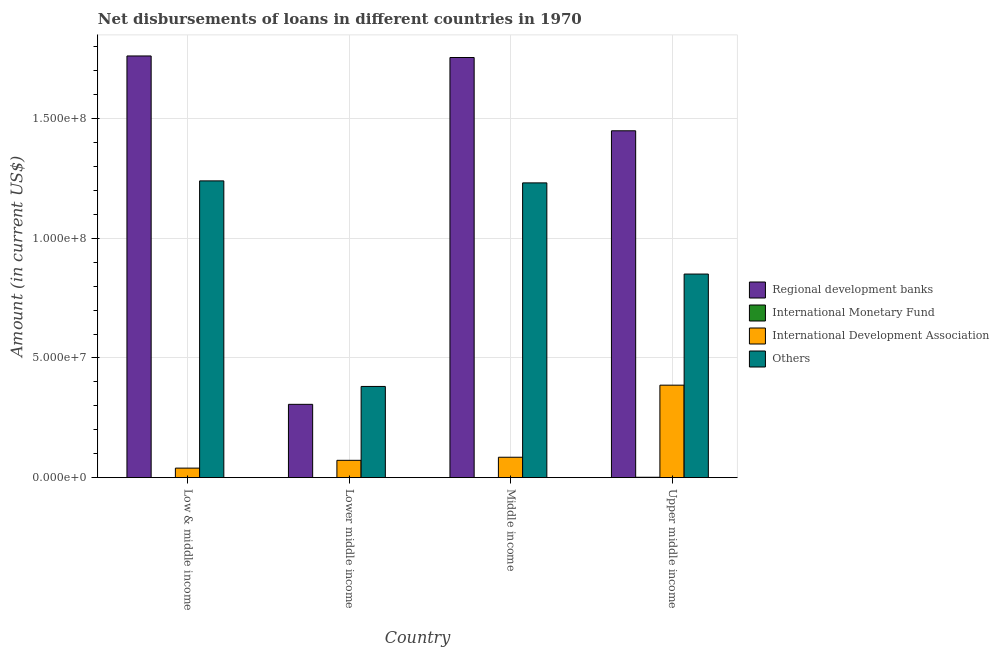How many different coloured bars are there?
Keep it short and to the point. 4. How many groups of bars are there?
Make the answer very short. 4. Are the number of bars per tick equal to the number of legend labels?
Your answer should be very brief. No. How many bars are there on the 3rd tick from the right?
Make the answer very short. 3. What is the label of the 3rd group of bars from the left?
Offer a terse response. Middle income. In how many cases, is the number of bars for a given country not equal to the number of legend labels?
Your response must be concise. 3. What is the amount of loan disimbursed by other organisations in Lower middle income?
Provide a succinct answer. 3.81e+07. Across all countries, what is the maximum amount of loan disimbursed by international development association?
Provide a short and direct response. 3.86e+07. Across all countries, what is the minimum amount of loan disimbursed by regional development banks?
Offer a very short reply. 3.06e+07. In which country was the amount of loan disimbursed by international monetary fund maximum?
Give a very brief answer. Upper middle income. What is the total amount of loan disimbursed by regional development banks in the graph?
Offer a very short reply. 5.27e+08. What is the difference between the amount of loan disimbursed by regional development banks in Lower middle income and that in Upper middle income?
Your response must be concise. -1.14e+08. What is the difference between the amount of loan disimbursed by regional development banks in Lower middle income and the amount of loan disimbursed by international monetary fund in Middle income?
Make the answer very short. 3.06e+07. What is the average amount of loan disimbursed by international development association per country?
Your answer should be very brief. 1.46e+07. What is the difference between the amount of loan disimbursed by international development association and amount of loan disimbursed by other organisations in Middle income?
Keep it short and to the point. -1.15e+08. What is the ratio of the amount of loan disimbursed by other organisations in Lower middle income to that in Middle income?
Make the answer very short. 0.31. What is the difference between the highest and the second highest amount of loan disimbursed by other organisations?
Your answer should be very brief. 8.35e+05. What is the difference between the highest and the lowest amount of loan disimbursed by other organisations?
Provide a short and direct response. 8.59e+07. Is the sum of the amount of loan disimbursed by international development association in Low & middle income and Lower middle income greater than the maximum amount of loan disimbursed by regional development banks across all countries?
Your answer should be compact. No. Is it the case that in every country, the sum of the amount of loan disimbursed by regional development banks and amount of loan disimbursed by international monetary fund is greater than the amount of loan disimbursed by international development association?
Offer a terse response. Yes. How many bars are there?
Ensure brevity in your answer.  13. How many countries are there in the graph?
Provide a short and direct response. 4. Are the values on the major ticks of Y-axis written in scientific E-notation?
Make the answer very short. Yes. Does the graph contain any zero values?
Offer a very short reply. Yes. Does the graph contain grids?
Make the answer very short. Yes. Where does the legend appear in the graph?
Make the answer very short. Center right. What is the title of the graph?
Give a very brief answer. Net disbursements of loans in different countries in 1970. What is the label or title of the X-axis?
Give a very brief answer. Country. What is the label or title of the Y-axis?
Offer a terse response. Amount (in current US$). What is the Amount (in current US$) in Regional development banks in Low & middle income?
Make the answer very short. 1.76e+08. What is the Amount (in current US$) in International Monetary Fund in Low & middle income?
Provide a short and direct response. 0. What is the Amount (in current US$) of International Development Association in Low & middle income?
Keep it short and to the point. 3.98e+06. What is the Amount (in current US$) of Others in Low & middle income?
Provide a short and direct response. 1.24e+08. What is the Amount (in current US$) in Regional development banks in Lower middle income?
Keep it short and to the point. 3.06e+07. What is the Amount (in current US$) in International Monetary Fund in Lower middle income?
Your answer should be very brief. 0. What is the Amount (in current US$) of International Development Association in Lower middle income?
Provide a succinct answer. 7.23e+06. What is the Amount (in current US$) in Others in Lower middle income?
Keep it short and to the point. 3.81e+07. What is the Amount (in current US$) in Regional development banks in Middle income?
Your answer should be compact. 1.76e+08. What is the Amount (in current US$) of International Monetary Fund in Middle income?
Your answer should be very brief. 0. What is the Amount (in current US$) of International Development Association in Middle income?
Offer a very short reply. 8.52e+06. What is the Amount (in current US$) of Others in Middle income?
Your response must be concise. 1.23e+08. What is the Amount (in current US$) of Regional development banks in Upper middle income?
Your answer should be very brief. 1.45e+08. What is the Amount (in current US$) of International Monetary Fund in Upper middle income?
Your response must be concise. 1.50e+05. What is the Amount (in current US$) in International Development Association in Upper middle income?
Keep it short and to the point. 3.86e+07. What is the Amount (in current US$) in Others in Upper middle income?
Your answer should be very brief. 8.51e+07. Across all countries, what is the maximum Amount (in current US$) of Regional development banks?
Provide a short and direct response. 1.76e+08. Across all countries, what is the maximum Amount (in current US$) of International Monetary Fund?
Offer a very short reply. 1.50e+05. Across all countries, what is the maximum Amount (in current US$) of International Development Association?
Provide a short and direct response. 3.86e+07. Across all countries, what is the maximum Amount (in current US$) in Others?
Your answer should be very brief. 1.24e+08. Across all countries, what is the minimum Amount (in current US$) in Regional development banks?
Provide a short and direct response. 3.06e+07. Across all countries, what is the minimum Amount (in current US$) in International Development Association?
Provide a short and direct response. 3.98e+06. Across all countries, what is the minimum Amount (in current US$) in Others?
Provide a short and direct response. 3.81e+07. What is the total Amount (in current US$) in Regional development banks in the graph?
Your response must be concise. 5.27e+08. What is the total Amount (in current US$) of International Monetary Fund in the graph?
Give a very brief answer. 1.50e+05. What is the total Amount (in current US$) in International Development Association in the graph?
Your answer should be compact. 5.84e+07. What is the total Amount (in current US$) in Others in the graph?
Make the answer very short. 3.70e+08. What is the difference between the Amount (in current US$) of Regional development banks in Low & middle income and that in Lower middle income?
Provide a short and direct response. 1.46e+08. What is the difference between the Amount (in current US$) in International Development Association in Low & middle income and that in Lower middle income?
Keep it short and to the point. -3.26e+06. What is the difference between the Amount (in current US$) in Others in Low & middle income and that in Lower middle income?
Ensure brevity in your answer.  8.59e+07. What is the difference between the Amount (in current US$) of Regional development banks in Low & middle income and that in Middle income?
Provide a short and direct response. 6.47e+05. What is the difference between the Amount (in current US$) of International Development Association in Low & middle income and that in Middle income?
Make the answer very short. -4.54e+06. What is the difference between the Amount (in current US$) of Others in Low & middle income and that in Middle income?
Offer a very short reply. 8.35e+05. What is the difference between the Amount (in current US$) of Regional development banks in Low & middle income and that in Upper middle income?
Make the answer very short. 3.13e+07. What is the difference between the Amount (in current US$) of International Development Association in Low & middle income and that in Upper middle income?
Your answer should be compact. -3.47e+07. What is the difference between the Amount (in current US$) of Others in Low & middle income and that in Upper middle income?
Your answer should be compact. 3.89e+07. What is the difference between the Amount (in current US$) of Regional development banks in Lower middle income and that in Middle income?
Make the answer very short. -1.45e+08. What is the difference between the Amount (in current US$) in International Development Association in Lower middle income and that in Middle income?
Your answer should be compact. -1.28e+06. What is the difference between the Amount (in current US$) of Others in Lower middle income and that in Middle income?
Your answer should be very brief. -8.51e+07. What is the difference between the Amount (in current US$) of Regional development banks in Lower middle income and that in Upper middle income?
Your answer should be very brief. -1.14e+08. What is the difference between the Amount (in current US$) of International Development Association in Lower middle income and that in Upper middle income?
Ensure brevity in your answer.  -3.14e+07. What is the difference between the Amount (in current US$) of Others in Lower middle income and that in Upper middle income?
Your response must be concise. -4.70e+07. What is the difference between the Amount (in current US$) in Regional development banks in Middle income and that in Upper middle income?
Offer a terse response. 3.06e+07. What is the difference between the Amount (in current US$) of International Development Association in Middle income and that in Upper middle income?
Your response must be concise. -3.01e+07. What is the difference between the Amount (in current US$) of Others in Middle income and that in Upper middle income?
Your answer should be very brief. 3.81e+07. What is the difference between the Amount (in current US$) of Regional development banks in Low & middle income and the Amount (in current US$) of International Development Association in Lower middle income?
Your response must be concise. 1.69e+08. What is the difference between the Amount (in current US$) in Regional development banks in Low & middle income and the Amount (in current US$) in Others in Lower middle income?
Offer a very short reply. 1.38e+08. What is the difference between the Amount (in current US$) of International Development Association in Low & middle income and the Amount (in current US$) of Others in Lower middle income?
Make the answer very short. -3.41e+07. What is the difference between the Amount (in current US$) of Regional development banks in Low & middle income and the Amount (in current US$) of International Development Association in Middle income?
Give a very brief answer. 1.68e+08. What is the difference between the Amount (in current US$) in Regional development banks in Low & middle income and the Amount (in current US$) in Others in Middle income?
Ensure brevity in your answer.  5.30e+07. What is the difference between the Amount (in current US$) in International Development Association in Low & middle income and the Amount (in current US$) in Others in Middle income?
Provide a succinct answer. -1.19e+08. What is the difference between the Amount (in current US$) in Regional development banks in Low & middle income and the Amount (in current US$) in International Monetary Fund in Upper middle income?
Your answer should be compact. 1.76e+08. What is the difference between the Amount (in current US$) in Regional development banks in Low & middle income and the Amount (in current US$) in International Development Association in Upper middle income?
Keep it short and to the point. 1.38e+08. What is the difference between the Amount (in current US$) of Regional development banks in Low & middle income and the Amount (in current US$) of Others in Upper middle income?
Your answer should be compact. 9.11e+07. What is the difference between the Amount (in current US$) of International Development Association in Low & middle income and the Amount (in current US$) of Others in Upper middle income?
Give a very brief answer. -8.11e+07. What is the difference between the Amount (in current US$) in Regional development banks in Lower middle income and the Amount (in current US$) in International Development Association in Middle income?
Provide a succinct answer. 2.21e+07. What is the difference between the Amount (in current US$) in Regional development banks in Lower middle income and the Amount (in current US$) in Others in Middle income?
Offer a very short reply. -9.25e+07. What is the difference between the Amount (in current US$) of International Development Association in Lower middle income and the Amount (in current US$) of Others in Middle income?
Your answer should be compact. -1.16e+08. What is the difference between the Amount (in current US$) of Regional development banks in Lower middle income and the Amount (in current US$) of International Monetary Fund in Upper middle income?
Your response must be concise. 3.05e+07. What is the difference between the Amount (in current US$) in Regional development banks in Lower middle income and the Amount (in current US$) in International Development Association in Upper middle income?
Ensure brevity in your answer.  -8.01e+06. What is the difference between the Amount (in current US$) of Regional development banks in Lower middle income and the Amount (in current US$) of Others in Upper middle income?
Your answer should be compact. -5.44e+07. What is the difference between the Amount (in current US$) in International Development Association in Lower middle income and the Amount (in current US$) in Others in Upper middle income?
Offer a very short reply. -7.78e+07. What is the difference between the Amount (in current US$) in Regional development banks in Middle income and the Amount (in current US$) in International Monetary Fund in Upper middle income?
Give a very brief answer. 1.75e+08. What is the difference between the Amount (in current US$) of Regional development banks in Middle income and the Amount (in current US$) of International Development Association in Upper middle income?
Your answer should be compact. 1.37e+08. What is the difference between the Amount (in current US$) in Regional development banks in Middle income and the Amount (in current US$) in Others in Upper middle income?
Ensure brevity in your answer.  9.05e+07. What is the difference between the Amount (in current US$) of International Development Association in Middle income and the Amount (in current US$) of Others in Upper middle income?
Your answer should be compact. -7.65e+07. What is the average Amount (in current US$) in Regional development banks per country?
Make the answer very short. 1.32e+08. What is the average Amount (in current US$) in International Monetary Fund per country?
Offer a very short reply. 3.75e+04. What is the average Amount (in current US$) in International Development Association per country?
Keep it short and to the point. 1.46e+07. What is the average Amount (in current US$) of Others per country?
Your answer should be very brief. 9.26e+07. What is the difference between the Amount (in current US$) in Regional development banks and Amount (in current US$) in International Development Association in Low & middle income?
Your answer should be very brief. 1.72e+08. What is the difference between the Amount (in current US$) of Regional development banks and Amount (in current US$) of Others in Low & middle income?
Your answer should be compact. 5.22e+07. What is the difference between the Amount (in current US$) in International Development Association and Amount (in current US$) in Others in Low & middle income?
Your answer should be very brief. -1.20e+08. What is the difference between the Amount (in current US$) of Regional development banks and Amount (in current US$) of International Development Association in Lower middle income?
Your answer should be compact. 2.34e+07. What is the difference between the Amount (in current US$) of Regional development banks and Amount (in current US$) of Others in Lower middle income?
Keep it short and to the point. -7.48e+06. What is the difference between the Amount (in current US$) in International Development Association and Amount (in current US$) in Others in Lower middle income?
Keep it short and to the point. -3.09e+07. What is the difference between the Amount (in current US$) of Regional development banks and Amount (in current US$) of International Development Association in Middle income?
Make the answer very short. 1.67e+08. What is the difference between the Amount (in current US$) of Regional development banks and Amount (in current US$) of Others in Middle income?
Make the answer very short. 5.24e+07. What is the difference between the Amount (in current US$) of International Development Association and Amount (in current US$) of Others in Middle income?
Your response must be concise. -1.15e+08. What is the difference between the Amount (in current US$) of Regional development banks and Amount (in current US$) of International Monetary Fund in Upper middle income?
Your answer should be very brief. 1.45e+08. What is the difference between the Amount (in current US$) in Regional development banks and Amount (in current US$) in International Development Association in Upper middle income?
Keep it short and to the point. 1.06e+08. What is the difference between the Amount (in current US$) of Regional development banks and Amount (in current US$) of Others in Upper middle income?
Give a very brief answer. 5.99e+07. What is the difference between the Amount (in current US$) in International Monetary Fund and Amount (in current US$) in International Development Association in Upper middle income?
Provide a succinct answer. -3.85e+07. What is the difference between the Amount (in current US$) in International Monetary Fund and Amount (in current US$) in Others in Upper middle income?
Provide a short and direct response. -8.49e+07. What is the difference between the Amount (in current US$) in International Development Association and Amount (in current US$) in Others in Upper middle income?
Offer a terse response. -4.64e+07. What is the ratio of the Amount (in current US$) of Regional development banks in Low & middle income to that in Lower middle income?
Give a very brief answer. 5.75. What is the ratio of the Amount (in current US$) of International Development Association in Low & middle income to that in Lower middle income?
Your answer should be compact. 0.55. What is the ratio of the Amount (in current US$) of Others in Low & middle income to that in Lower middle income?
Ensure brevity in your answer.  3.25. What is the ratio of the Amount (in current US$) of Regional development banks in Low & middle income to that in Middle income?
Offer a very short reply. 1. What is the ratio of the Amount (in current US$) of International Development Association in Low & middle income to that in Middle income?
Your answer should be very brief. 0.47. What is the ratio of the Amount (in current US$) of Others in Low & middle income to that in Middle income?
Offer a terse response. 1.01. What is the ratio of the Amount (in current US$) of Regional development banks in Low & middle income to that in Upper middle income?
Provide a short and direct response. 1.22. What is the ratio of the Amount (in current US$) in International Development Association in Low & middle income to that in Upper middle income?
Provide a short and direct response. 0.1. What is the ratio of the Amount (in current US$) of Others in Low & middle income to that in Upper middle income?
Provide a short and direct response. 1.46. What is the ratio of the Amount (in current US$) in Regional development banks in Lower middle income to that in Middle income?
Your response must be concise. 0.17. What is the ratio of the Amount (in current US$) in International Development Association in Lower middle income to that in Middle income?
Your answer should be compact. 0.85. What is the ratio of the Amount (in current US$) in Others in Lower middle income to that in Middle income?
Your answer should be very brief. 0.31. What is the ratio of the Amount (in current US$) in Regional development banks in Lower middle income to that in Upper middle income?
Offer a very short reply. 0.21. What is the ratio of the Amount (in current US$) of International Development Association in Lower middle income to that in Upper middle income?
Make the answer very short. 0.19. What is the ratio of the Amount (in current US$) of Others in Lower middle income to that in Upper middle income?
Provide a short and direct response. 0.45. What is the ratio of the Amount (in current US$) of Regional development banks in Middle income to that in Upper middle income?
Keep it short and to the point. 1.21. What is the ratio of the Amount (in current US$) of International Development Association in Middle income to that in Upper middle income?
Offer a terse response. 0.22. What is the ratio of the Amount (in current US$) of Others in Middle income to that in Upper middle income?
Offer a terse response. 1.45. What is the difference between the highest and the second highest Amount (in current US$) of Regional development banks?
Keep it short and to the point. 6.47e+05. What is the difference between the highest and the second highest Amount (in current US$) in International Development Association?
Ensure brevity in your answer.  3.01e+07. What is the difference between the highest and the second highest Amount (in current US$) in Others?
Your answer should be compact. 8.35e+05. What is the difference between the highest and the lowest Amount (in current US$) in Regional development banks?
Provide a succinct answer. 1.46e+08. What is the difference between the highest and the lowest Amount (in current US$) in International Development Association?
Keep it short and to the point. 3.47e+07. What is the difference between the highest and the lowest Amount (in current US$) of Others?
Provide a succinct answer. 8.59e+07. 